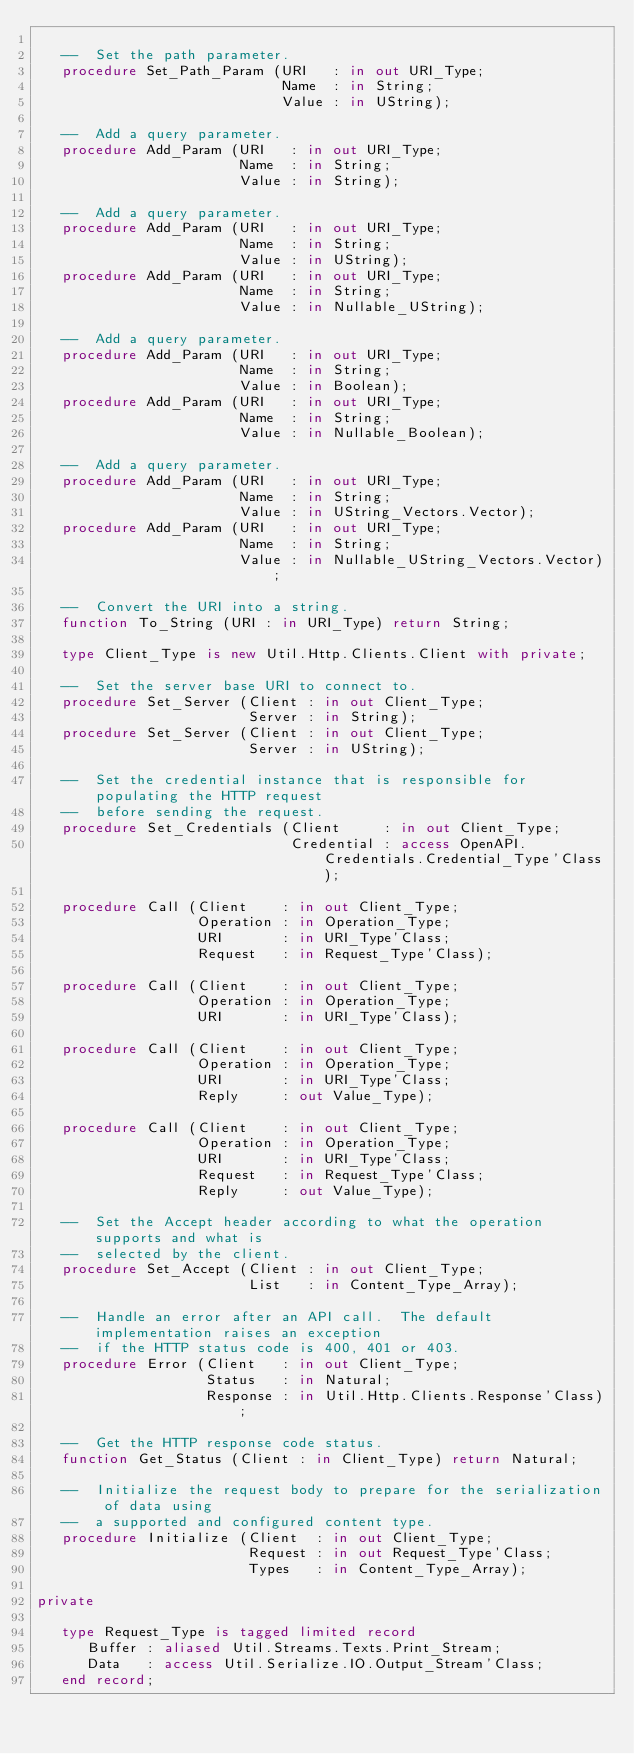<code> <loc_0><loc_0><loc_500><loc_500><_Ada_>
   --  Set the path parameter.
   procedure Set_Path_Param (URI   : in out URI_Type;
                             Name  : in String;
                             Value : in UString);

   --  Add a query parameter.
   procedure Add_Param (URI   : in out URI_Type;
                        Name  : in String;
                        Value : in String);

   --  Add a query parameter.
   procedure Add_Param (URI   : in out URI_Type;
                        Name  : in String;
                        Value : in UString);
   procedure Add_Param (URI   : in out URI_Type;
                        Name  : in String;
                        Value : in Nullable_UString);

   --  Add a query parameter.
   procedure Add_Param (URI   : in out URI_Type;
                        Name  : in String;
                        Value : in Boolean);
   procedure Add_Param (URI   : in out URI_Type;
                        Name  : in String;
                        Value : in Nullable_Boolean);

   --  Add a query parameter.
   procedure Add_Param (URI   : in out URI_Type;
                        Name  : in String;
                        Value : in UString_Vectors.Vector);
   procedure Add_Param (URI   : in out URI_Type;
                        Name  : in String;
                        Value : in Nullable_UString_Vectors.Vector);

   --  Convert the URI into a string.
   function To_String (URI : in URI_Type) return String;

   type Client_Type is new Util.Http.Clients.Client with private;

   --  Set the server base URI to connect to.
   procedure Set_Server (Client : in out Client_Type;
                         Server : in String);
   procedure Set_Server (Client : in out Client_Type;
                         Server : in UString);

   --  Set the credential instance that is responsible for populating the HTTP request
   --  before sending the request.
   procedure Set_Credentials (Client     : in out Client_Type;
                              Credential : access OpenAPI.Credentials.Credential_Type'Class);

   procedure Call (Client    : in out Client_Type;
                   Operation : in Operation_Type;
                   URI       : in URI_Type'Class;
                   Request   : in Request_Type'Class);

   procedure Call (Client    : in out Client_Type;
                   Operation : in Operation_Type;
                   URI       : in URI_Type'Class);

   procedure Call (Client    : in out Client_Type;
                   Operation : in Operation_Type;
                   URI       : in URI_Type'Class;
                   Reply     : out Value_Type);

   procedure Call (Client    : in out Client_Type;
                   Operation : in Operation_Type;
                   URI       : in URI_Type'Class;
                   Request   : in Request_Type'Class;
                   Reply     : out Value_Type);

   --  Set the Accept header according to what the operation supports and what is
   --  selected by the client.
   procedure Set_Accept (Client : in out Client_Type;
                         List   : in Content_Type_Array);

   --  Handle an error after an API call.  The default implementation raises an exception
   --  if the HTTP status code is 400, 401 or 403.
   procedure Error (Client   : in out Client_Type;
                    Status   : in Natural;
                    Response : in Util.Http.Clients.Response'Class);

   --  Get the HTTP response code status.
   function Get_Status (Client : in Client_Type) return Natural;

   --  Initialize the request body to prepare for the serialization of data using
   --  a supported and configured content type.
   procedure Initialize (Client  : in out Client_Type;
                         Request : in out Request_Type'Class;
                         Types   : in Content_Type_Array);

private

   type Request_Type is tagged limited record
      Buffer : aliased Util.Streams.Texts.Print_Stream;
      Data   : access Util.Serialize.IO.Output_Stream'Class;
   end record;
</code> 